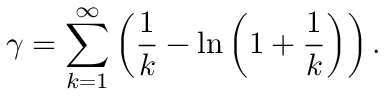Convert formula to latex. <formula><loc_0><loc_0><loc_500><loc_500>\gamma = \sum _ { k = 1 } ^ { \infty } \left ( { \frac { 1 } { k } } - \ln \left ( 1 + { \frac { 1 } { k } } \right ) \right ) .</formula> 